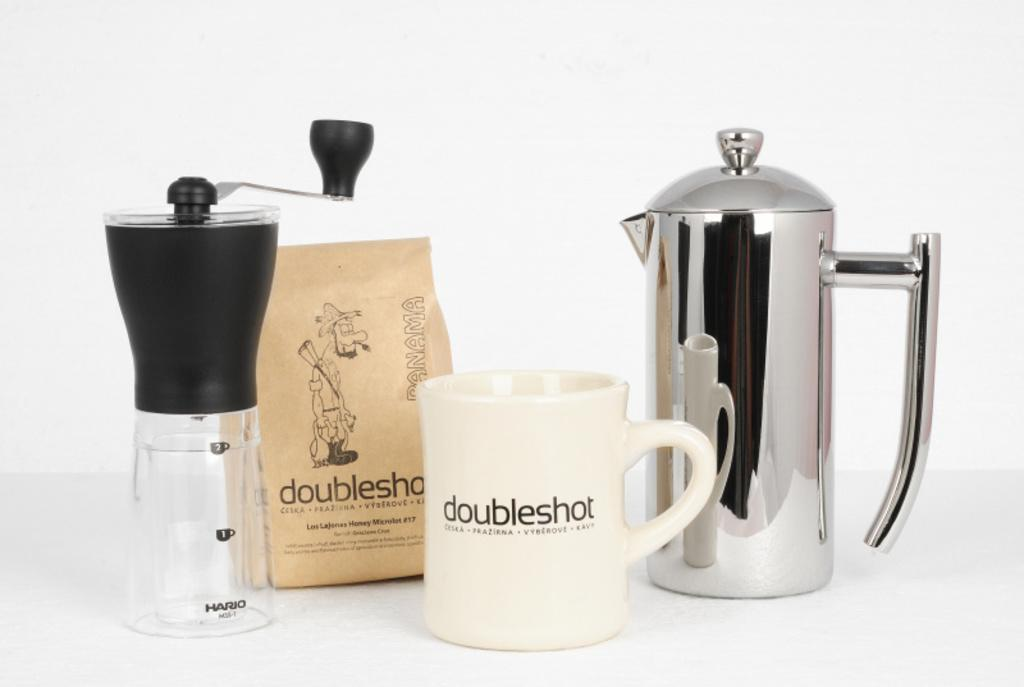Provide a one-sentence caption for the provided image. a white mug in front of other containers that says 'doubleshot' on it. 